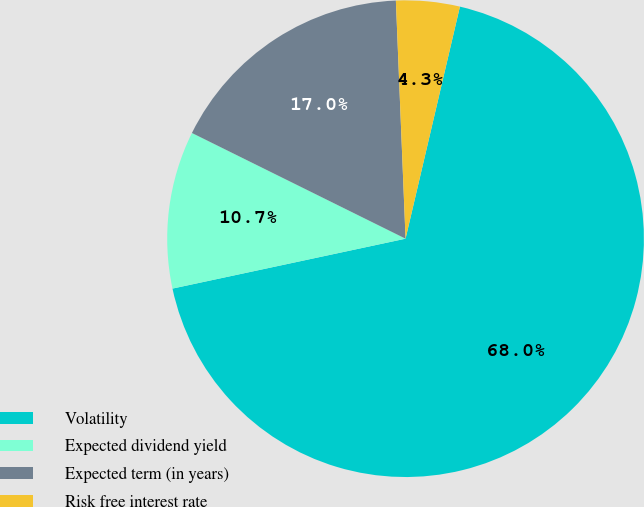Convert chart. <chart><loc_0><loc_0><loc_500><loc_500><pie_chart><fcel>Volatility<fcel>Expected dividend yield<fcel>Expected term (in years)<fcel>Risk free interest rate<nl><fcel>67.98%<fcel>10.67%<fcel>17.04%<fcel>4.31%<nl></chart> 